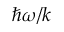<formula> <loc_0><loc_0><loc_500><loc_500>\hbar { \omega } / k</formula> 